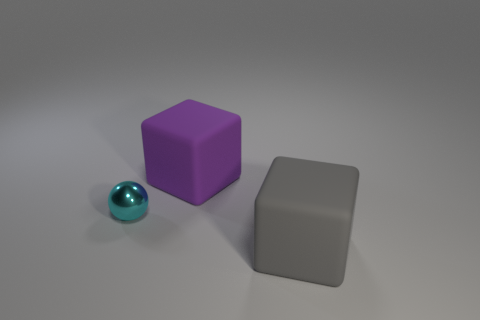Add 3 tiny green rubber cylinders. How many objects exist? 6 Subtract all spheres. How many objects are left? 2 Add 2 blocks. How many blocks are left? 4 Add 3 small blue blocks. How many small blue blocks exist? 3 Subtract 0 blue cylinders. How many objects are left? 3 Subtract all big objects. Subtract all large gray rubber objects. How many objects are left? 0 